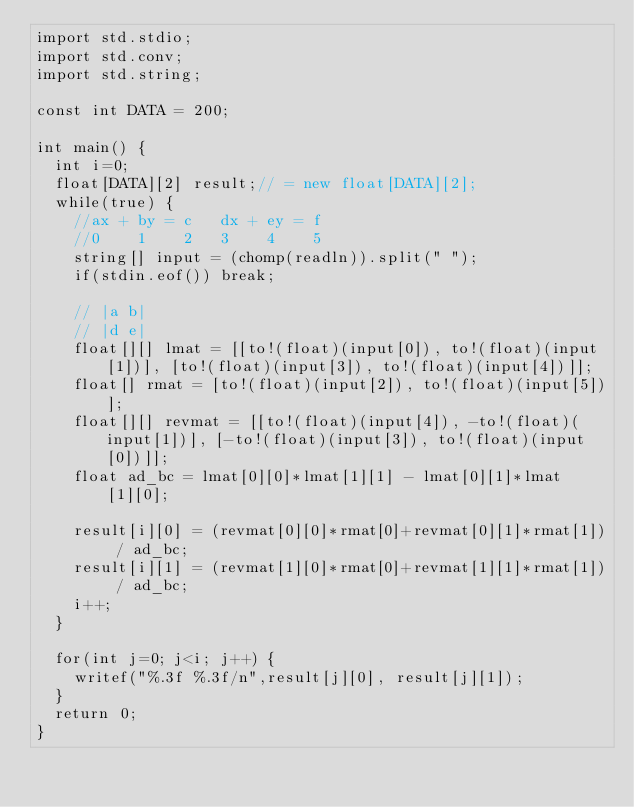Convert code to text. <code><loc_0><loc_0><loc_500><loc_500><_D_>import std.stdio;
import std.conv;
import std.string;

const int DATA = 200;

int main() {
  int i=0;
  float[DATA][2] result;// = new float[DATA][2];
  while(true) {
    //ax + by = c   dx + ey = f
    //0    1    2   3    4    5
    string[] input = (chomp(readln)).split(" ");
    if(stdin.eof()) break;
    
    // |a b|
    // |d e|
    float[][] lmat = [[to!(float)(input[0]), to!(float)(input[1])], [to!(float)(input[3]), to!(float)(input[4])]];
    float[] rmat = [to!(float)(input[2]), to!(float)(input[5])];
    float[][] revmat = [[to!(float)(input[4]), -to!(float)(input[1])], [-to!(float)(input[3]), to!(float)(input[0])]];
    float ad_bc = lmat[0][0]*lmat[1][1] - lmat[0][1]*lmat[1][0];

    result[i][0] = (revmat[0][0]*rmat[0]+revmat[0][1]*rmat[1]) / ad_bc;
    result[i][1] = (revmat[1][0]*rmat[0]+revmat[1][1]*rmat[1]) / ad_bc;
    i++;
  }

  for(int j=0; j<i; j++) {
    writef("%.3f %.3f/n",result[j][0], result[j][1]);
  }
  return 0;
}</code> 